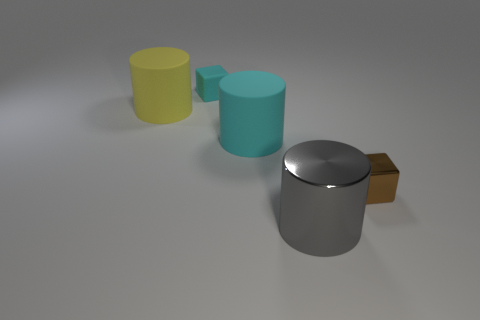Subtract all cyan cylinders. How many cylinders are left? 2 Add 4 brown shiny things. How many objects exist? 9 Subtract all yellow cylinders. How many cylinders are left? 2 Subtract all blocks. How many objects are left? 3 Subtract all red metal cylinders. Subtract all tiny matte cubes. How many objects are left? 4 Add 1 big cyan cylinders. How many big cyan cylinders are left? 2 Add 3 tiny cyan matte objects. How many tiny cyan matte objects exist? 4 Subtract 0 green blocks. How many objects are left? 5 Subtract all purple blocks. Subtract all purple cylinders. How many blocks are left? 2 